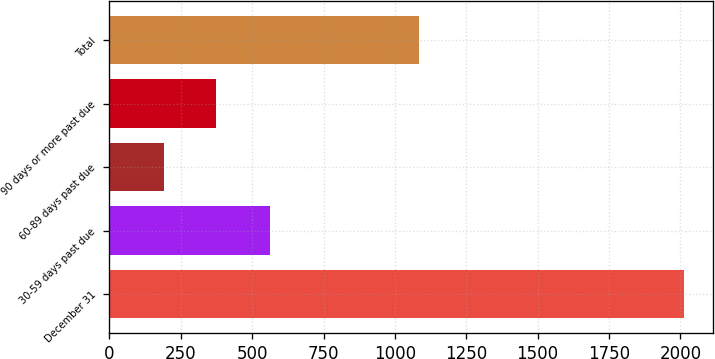Convert chart to OTSL. <chart><loc_0><loc_0><loc_500><loc_500><bar_chart><fcel>December 31<fcel>30-59 days past due<fcel>60-89 days past due<fcel>90 days or more past due<fcel>Total<nl><fcel>2012<fcel>563<fcel>190<fcel>372.2<fcel>1084<nl></chart> 